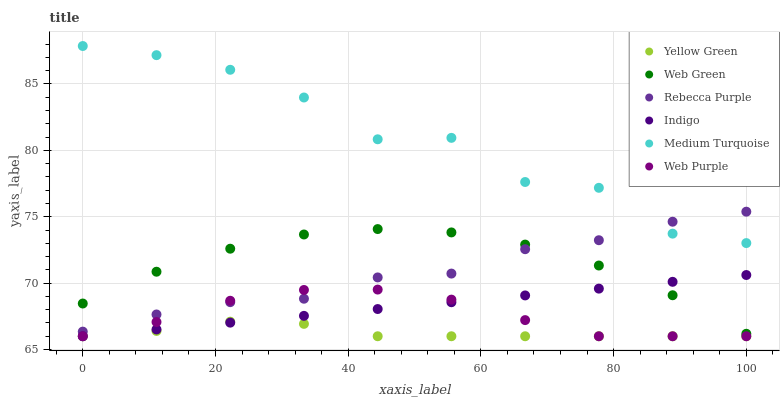Does Yellow Green have the minimum area under the curve?
Answer yes or no. Yes. Does Medium Turquoise have the maximum area under the curve?
Answer yes or no. Yes. Does Web Green have the minimum area under the curve?
Answer yes or no. No. Does Web Green have the maximum area under the curve?
Answer yes or no. No. Is Indigo the smoothest?
Answer yes or no. Yes. Is Medium Turquoise the roughest?
Answer yes or no. Yes. Is Yellow Green the smoothest?
Answer yes or no. No. Is Yellow Green the roughest?
Answer yes or no. No. Does Indigo have the lowest value?
Answer yes or no. Yes. Does Web Green have the lowest value?
Answer yes or no. No. Does Medium Turquoise have the highest value?
Answer yes or no. Yes. Does Web Green have the highest value?
Answer yes or no. No. Is Indigo less than Medium Turquoise?
Answer yes or no. Yes. Is Web Green greater than Yellow Green?
Answer yes or no. Yes. Does Web Green intersect Indigo?
Answer yes or no. Yes. Is Web Green less than Indigo?
Answer yes or no. No. Is Web Green greater than Indigo?
Answer yes or no. No. Does Indigo intersect Medium Turquoise?
Answer yes or no. No. 